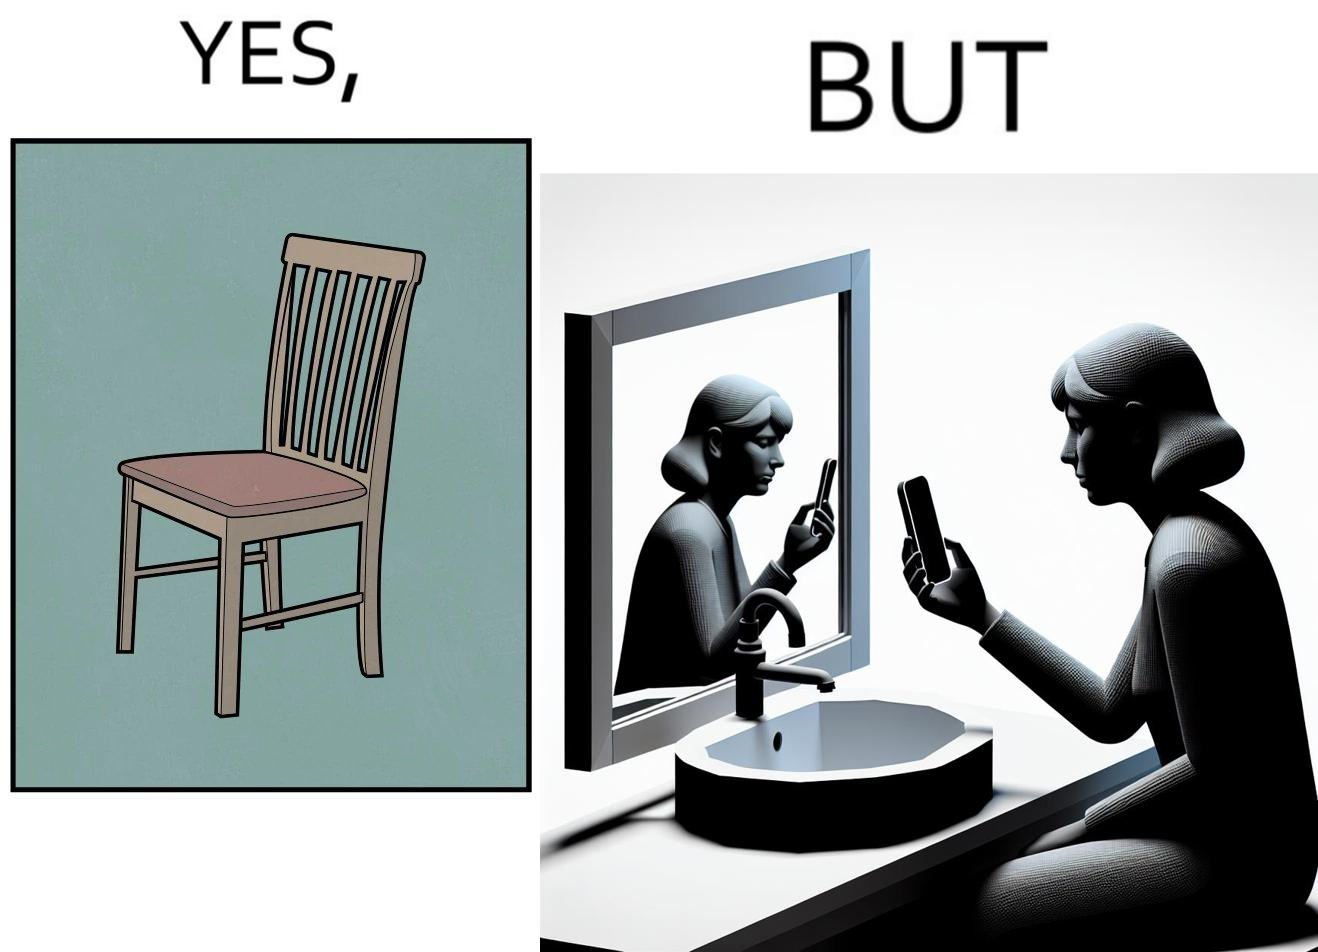What makes this image funny or satirical? The image is ironical, as a woman is sitting by the sink taking a selfie using a mirror, while not using a chair that is actually meant for sitting. 